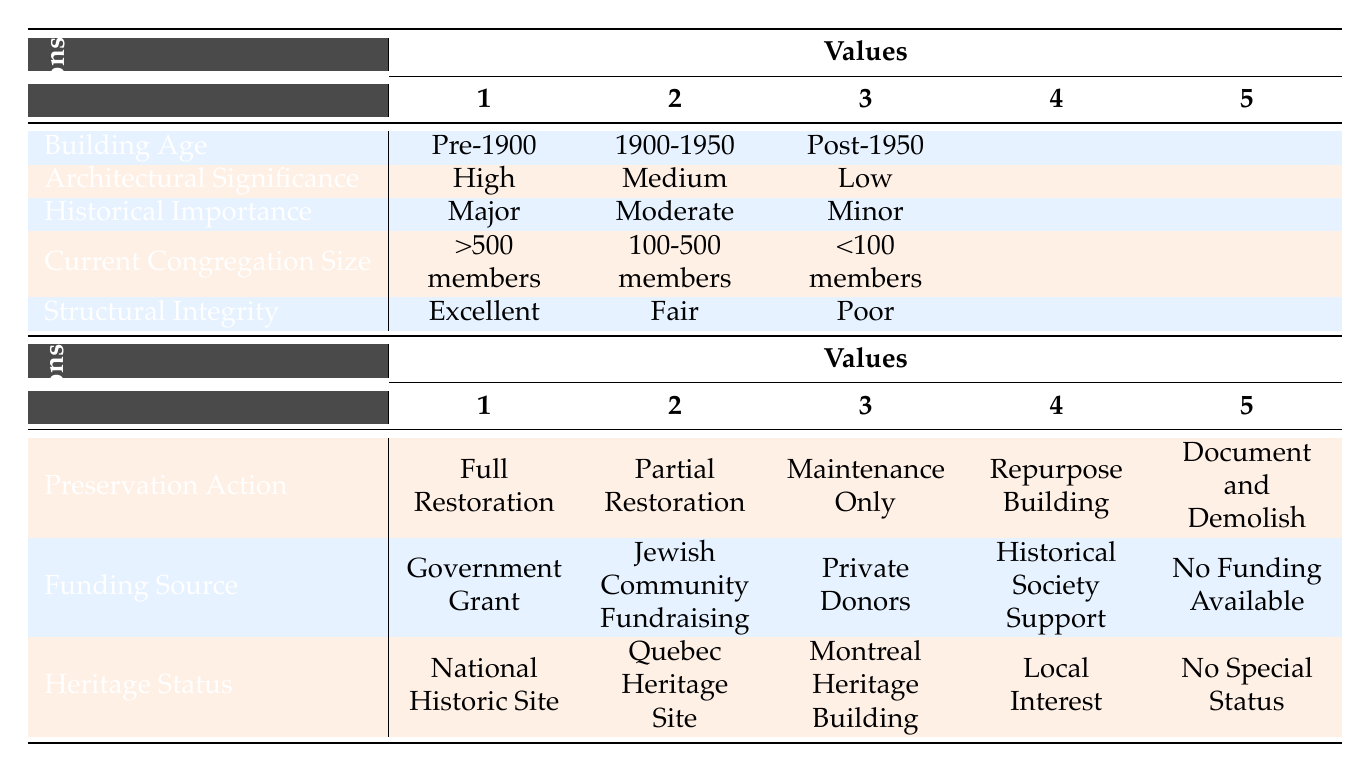What preservation action is recommended for buildings with high architectural significance and major historical importance? According to the table, for buildings that are of high architectural significance, major historical importance, and constructed before 1900, the recommended preservation action is full restoration, as detailed in the rules section.
Answer: Full Restoration Is government grant the funding source for buildings built between 1900 and 1950 with fair structural integrity? Yes, the table indicates that for buildings aged between 1900 and 1950, which have a medium architectural significance and moderate historical importance with a current congregation size of 100-500 members, the funding source is Jewish Community Fundraising, not a government grant.
Answer: No What is the heritage status for synagogues with poor structural integrity, minor historical importance, and a current congregation size of less than 100 members? The table specifies that synagogues fitting this description, which are post-1950 in age and low in architectural significance, are categorized as having no special status, as stated in the rules section.
Answer: No Special Status Are there any preservation actions that involve maintenance only? The table lists five preservation actions, and none of these include maintenance only as an option. Therefore, it can be concluded that maintenance only is not considered in the recommendations.
Answer: No Which type of funding source is applicable for synagogues that are designated as a national historic site? From the table data, synagogues that are categorized as national historic sites should have a funding source from the government grant, as this action is associated with full restoration for relevant historical and structural conditions.
Answer: Government Grant What is the average age of the buildings mentioned in the examples provided? The examples include three buildings: Shaar Hashomayim Synagogue (1922), Spanish and Portuguese Synagogue (1890), and Beth Israel Beth Aaron Congregation (1967). The average age can be computed as follows: (1922 + 1890 + 1967) / 3 = 1926.33. Thus, the average age can be approximated to 1926.
Answer: 1926 What preservation action is indicated for a synagogue built in 1967 with low architectural significance and a congregation size under 100? According to the table, a synagogue built post-1950 with low architectural significance, minor historical importance, poor structural integrity, and a small congregation size is advised to be documented and demolished, as outlined in the rules.
Answer: Document and Demolish Are there any synagogues with a funding source from historical society support? The table shows that historical society support is listed as a possible funding source, but there are no rules specified that apply this option, indicating there are no current conditions leading to this action.
Answer: No What condition of structural integrity corresponds with full restoration? The table notes that full restoration is applicable when the structural integrity of the building is classified as excellent, which aligns with the conditions for preservation actions.
Answer: Excellent 